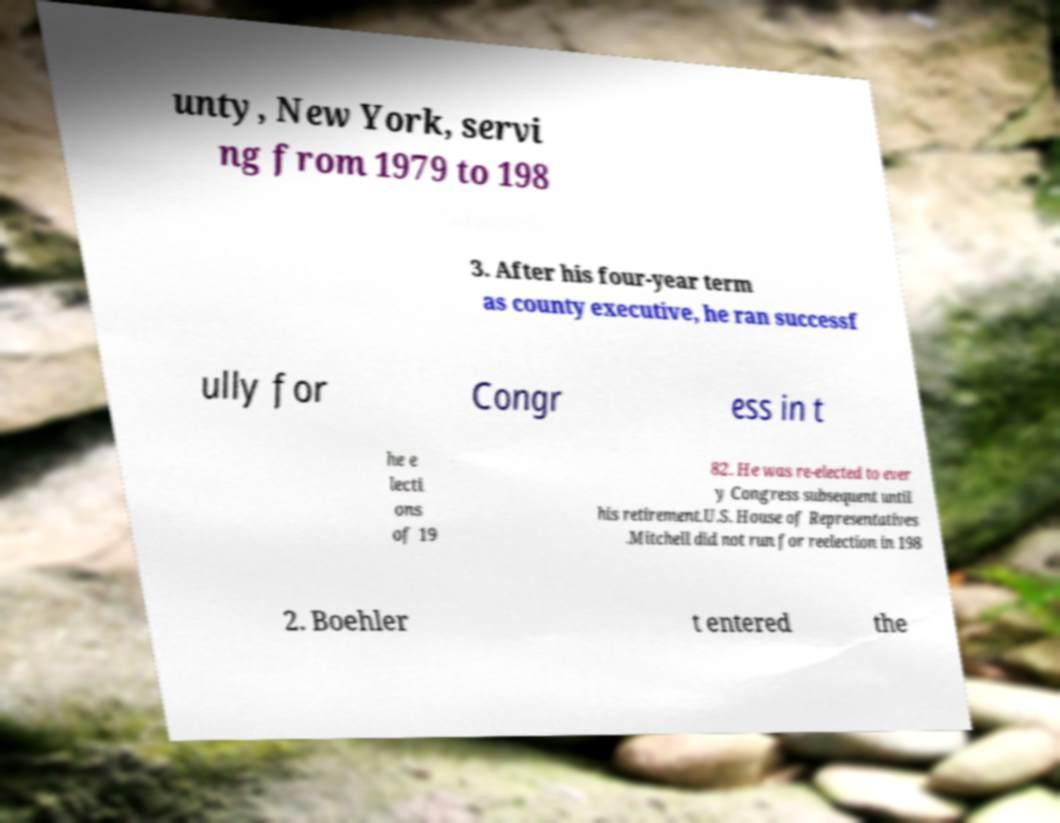Could you extract and type out the text from this image? unty, New York, servi ng from 1979 to 198 3. After his four-year term as county executive, he ran successf ully for Congr ess in t he e lecti ons of 19 82. He was re-elected to ever y Congress subsequent until his retirement.U.S. House of Representatives .Mitchell did not run for reelection in 198 2. Boehler t entered the 